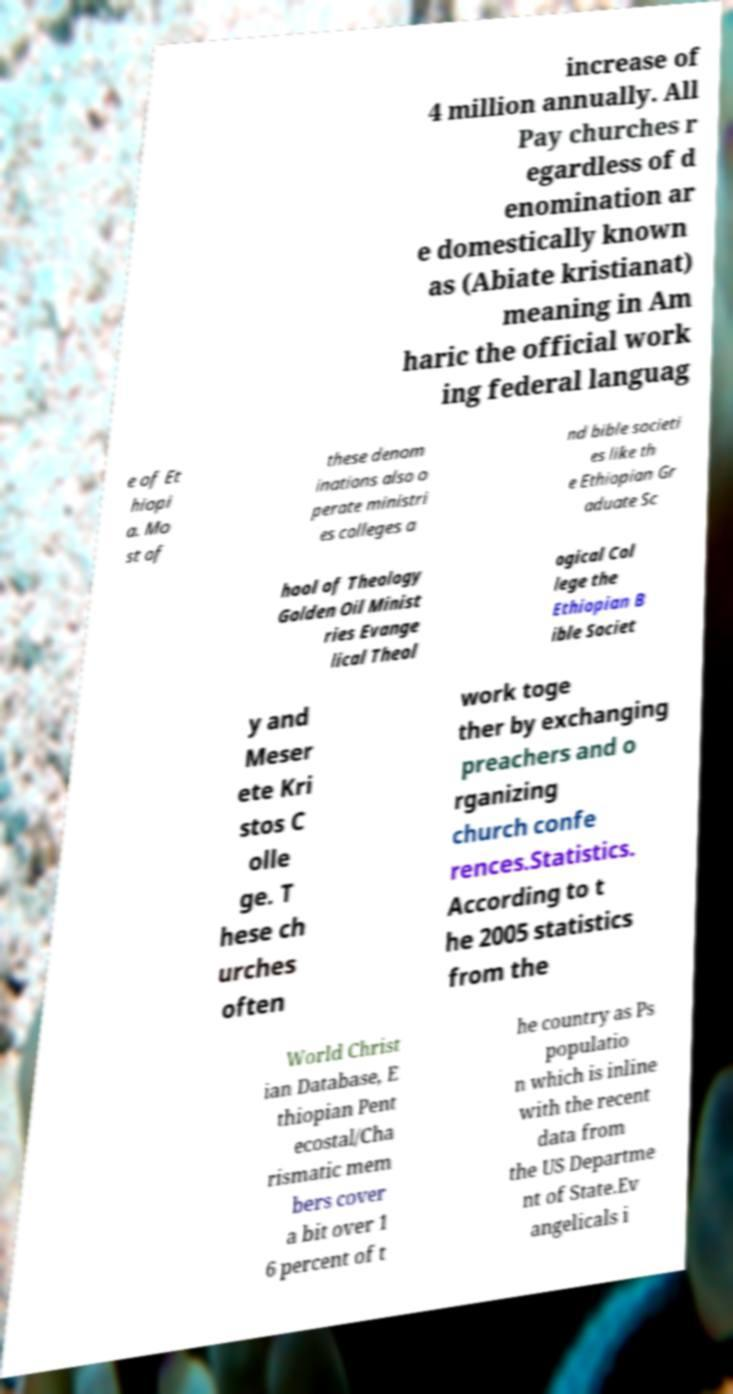Can you accurately transcribe the text from the provided image for me? increase of 4 million annually. All Pay churches r egardless of d enomination ar e domestically known as (Abiate kristianat) meaning in Am haric the official work ing federal languag e of Et hiopi a. Mo st of these denom inations also o perate ministri es colleges a nd bible societi es like th e Ethiopian Gr aduate Sc hool of Theology Golden Oil Minist ries Evange lical Theol ogical Col lege the Ethiopian B ible Societ y and Meser ete Kri stos C olle ge. T hese ch urches often work toge ther by exchanging preachers and o rganizing church confe rences.Statistics. According to t he 2005 statistics from the World Christ ian Database, E thiopian Pent ecostal/Cha rismatic mem bers cover a bit over 1 6 percent of t he country as Ps populatio n which is inline with the recent data from the US Departme nt of State.Ev angelicals i 